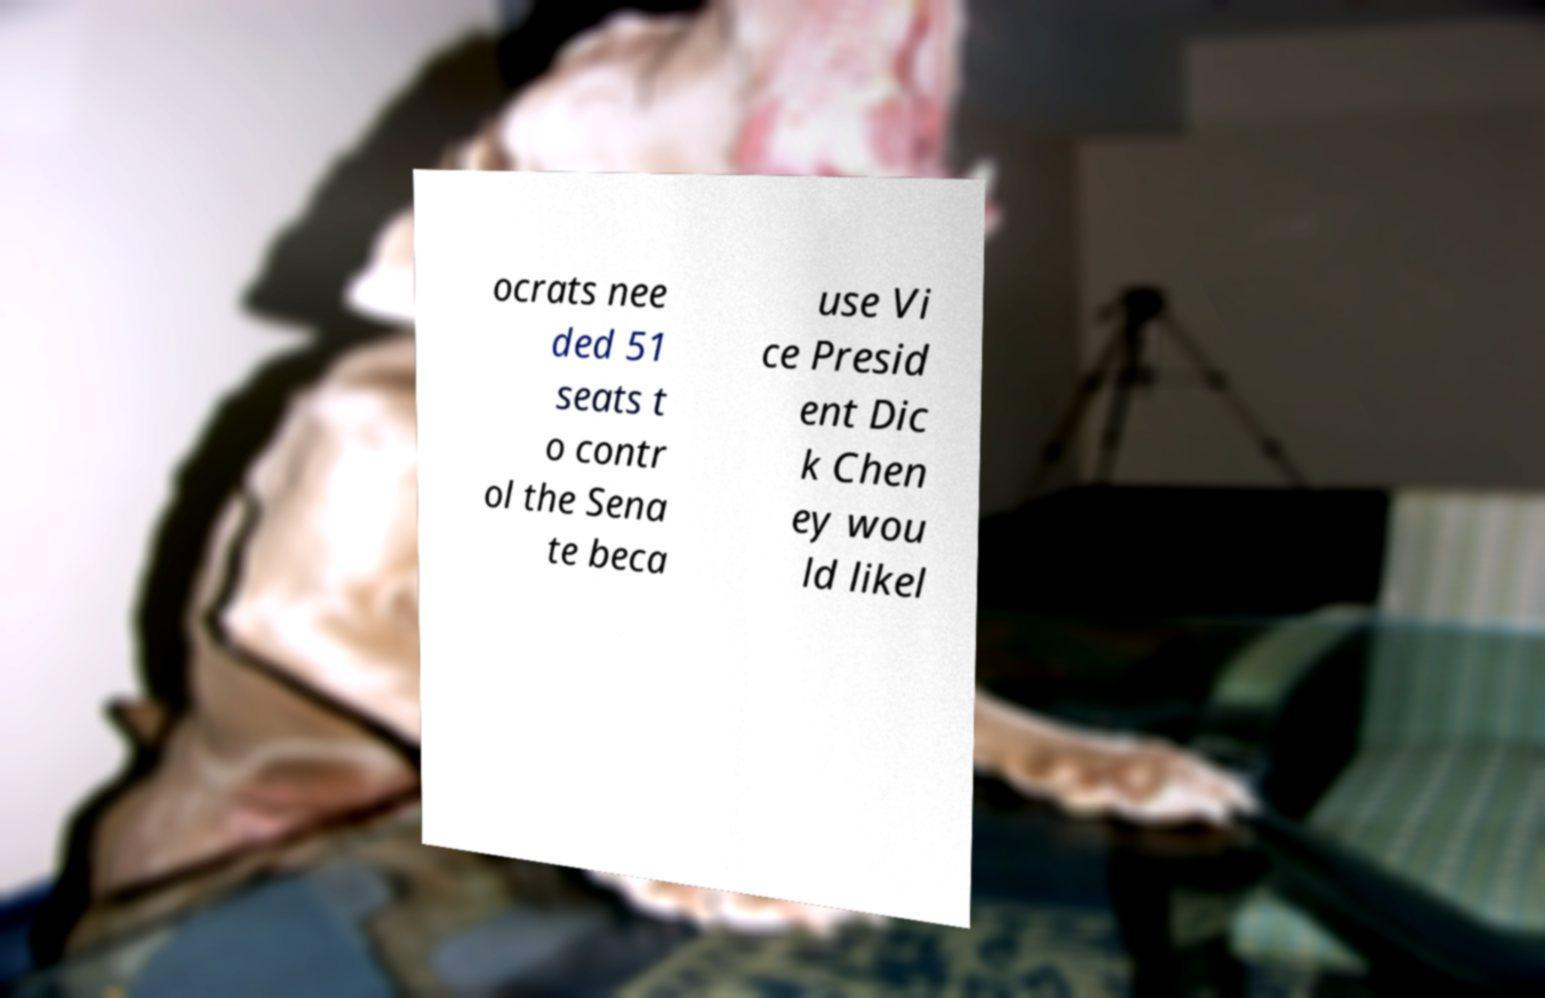For documentation purposes, I need the text within this image transcribed. Could you provide that? ocrats nee ded 51 seats t o contr ol the Sena te beca use Vi ce Presid ent Dic k Chen ey wou ld likel 